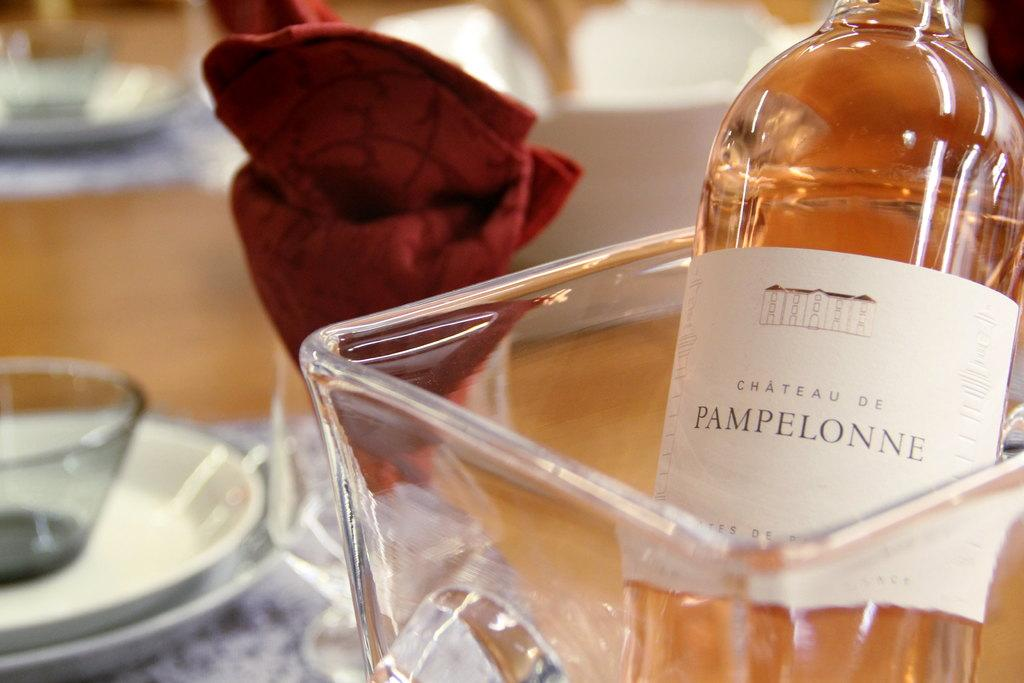<image>
Write a terse but informative summary of the picture. A bottle of CHATEAU DE PAMPALONNE sitting in a glass container. 